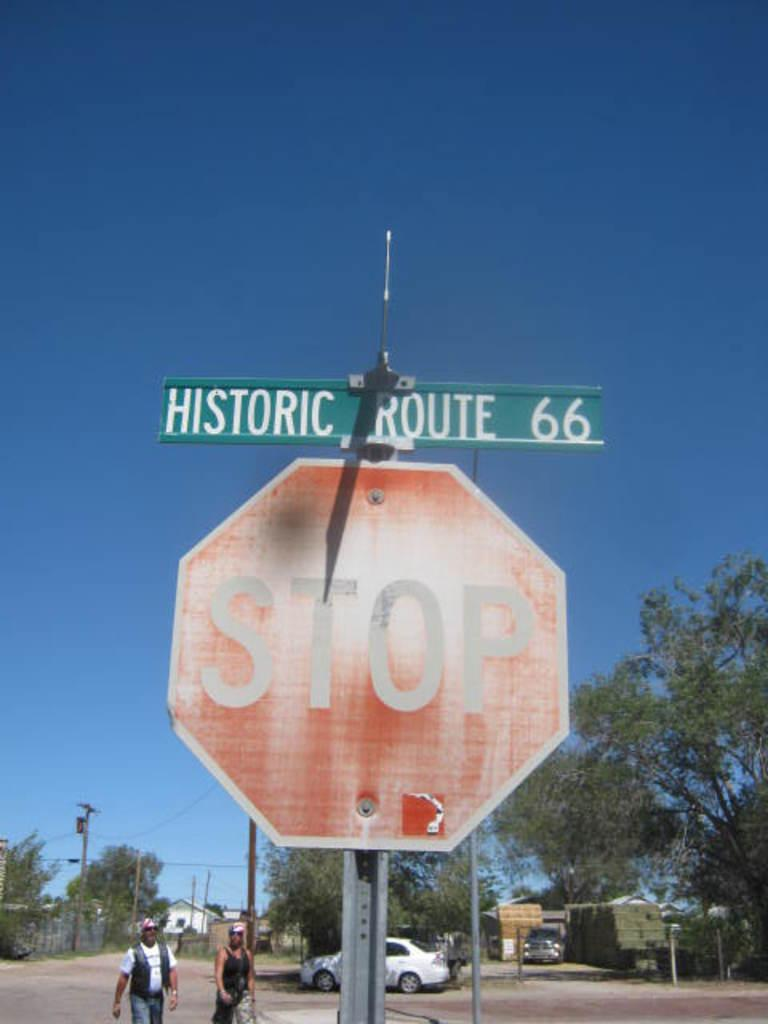<image>
Relay a brief, clear account of the picture shown. a stop sign at the intersection of the historic route 66 location 